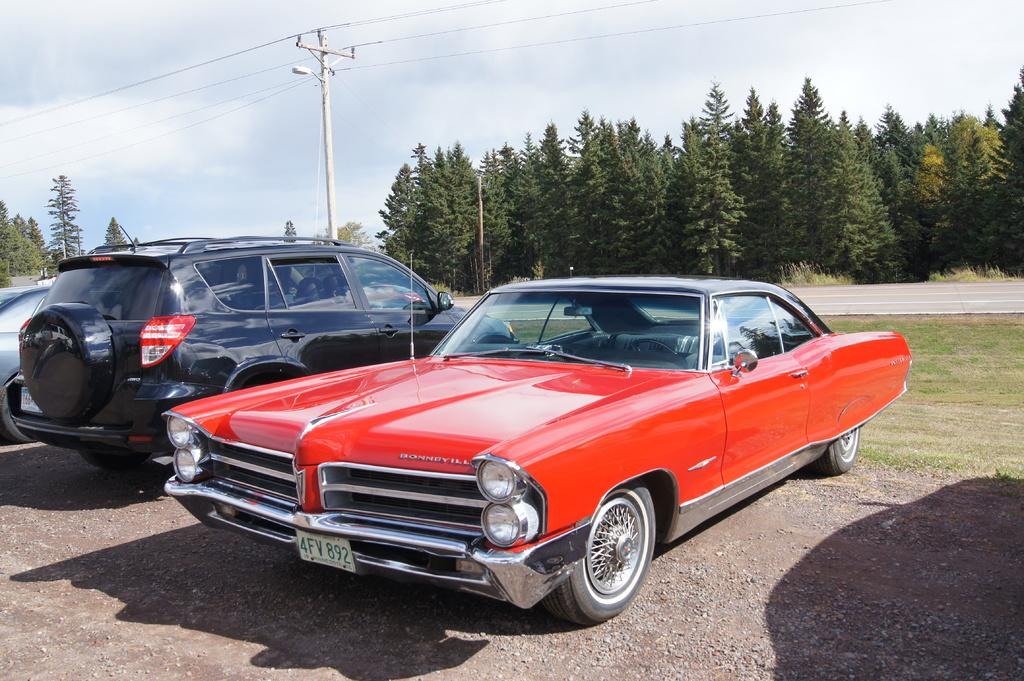How many cars are parked in the image? There are two cars parked in the image. What can be seen in the background of the image? There is an electric pole, cables, trees, and the sky in the background of the image. What is the condition of the sky in the image? The sky is clear in the image. What book is the sun reading in the image? There is no book or sun present in the image. What type of weather is depicted in the image? The provided facts do not mention any specific weather conditions; however, the clear sky suggests good weather. 